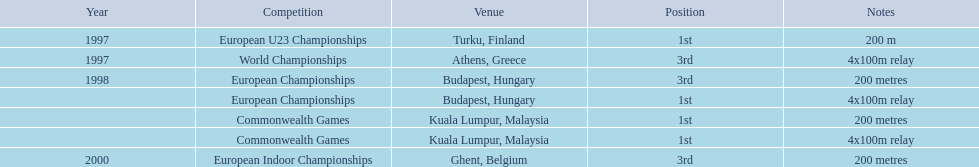What was the only event won in belgium? European Indoor Championships. 